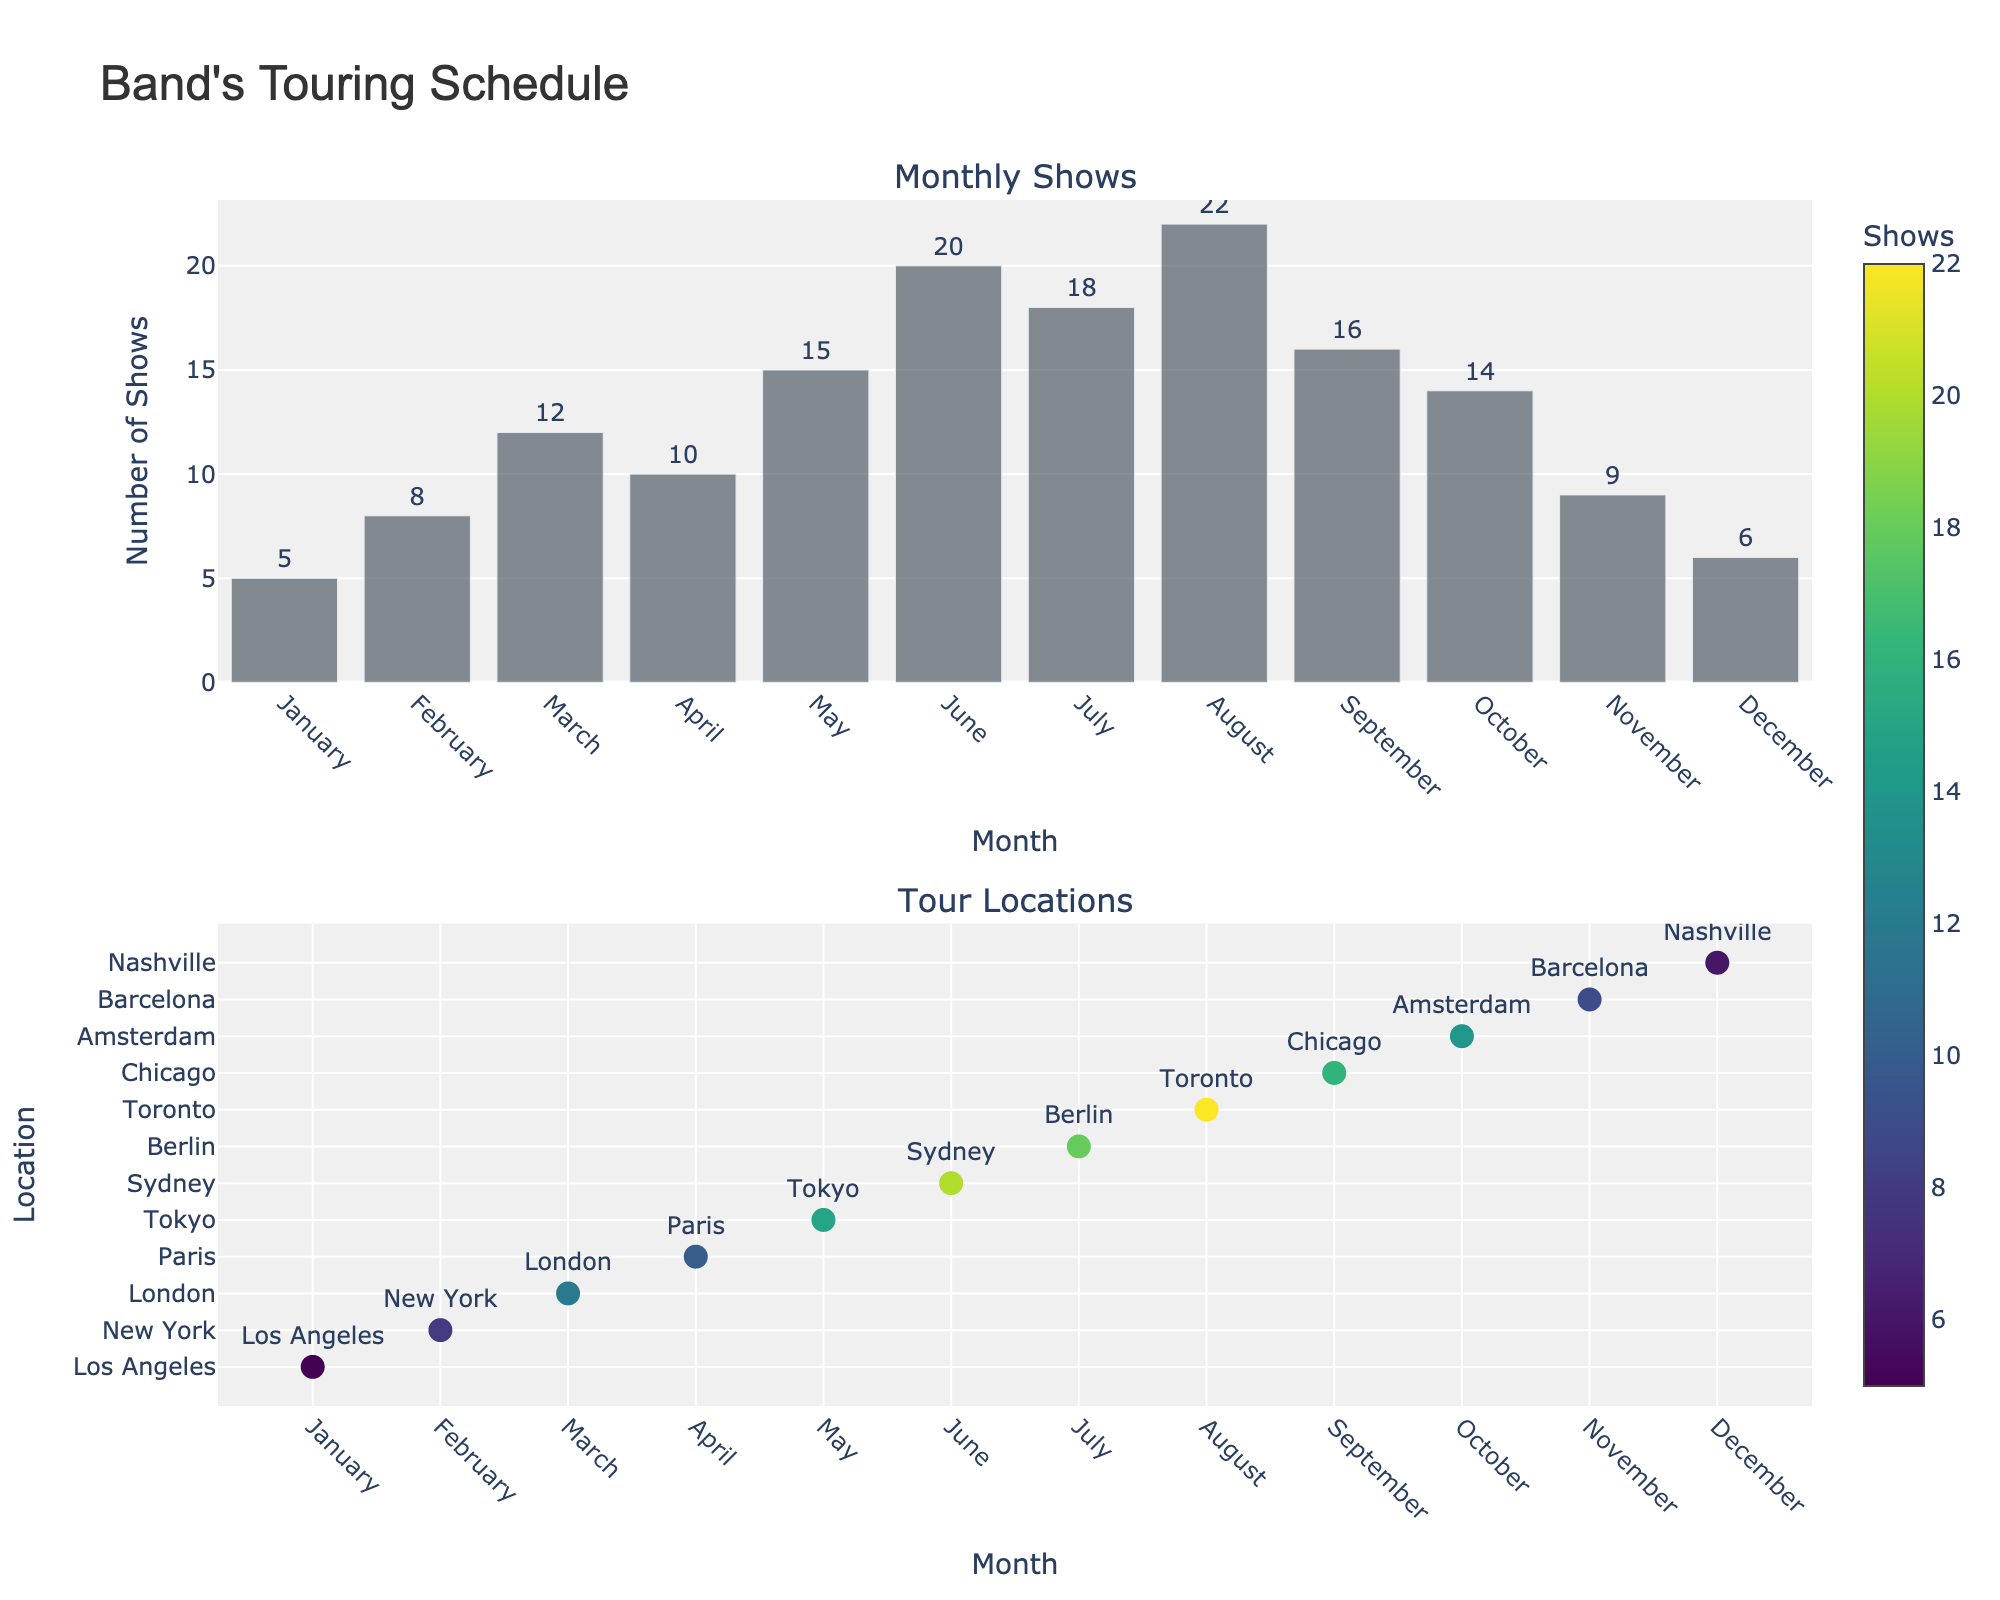What's the title of the figure? The title is usually displayed at the top of the figure. By looking at the figure, we can see that the title reads "Band's Touring Schedule."
Answer: Band's Touring Schedule How many shows did the band play in June? To find the number of shows played in June, look at the bar corresponding to June in the first subplot. The text label shows the number directly.
Answer: 20 Which month had the most shows? To determine the month with the most shows, look for the highest bar in the first subplot. The tallest bar is in August.
Answer: August What's the average number of shows per month? Calculate the average by summing the number of shows for each month and dividing by the number of months (12). (5+8+12+10+15+20+18+22+16+14+9+6)/12 = 13.25
Answer: 13.25 List all the locations where the band played shows in Europe. Look at the second subplot for locations and identify the ones in Europe. The European locations are London, Paris, Berlin, Amsterdam, and Barcelona.
Answer: London, Paris, Berlin, Amsterdam, Barcelona Which month had the lowest number of shows, and how many were there? Look for the shortest bar in the first subplot. The shortest bar is in January, showing 5 shows.
Answer: January, 5 Between July and August, which month had more shows, and how many more? Compare the bars for July and August in the first subplot. August (22) had more shows than July (18). The difference is 22 - 18 = 4.
Answer: August, 4 What is the total number of shows played by the band in the first quarter of the year? The first quarter includes January, February, and March. Add the number of shows in these months: 5 (Jan) + 8 (Feb) + 12 (Mar) = 25.
Answer: 25 Which two months had the closest number of shows, and what is the difference? By visually inspecting the bars in the first subplot, identify the closest ones. October (14) and November (9) show a difference of 1 show (although Berlin and Sydney might seem close but they are in different months).
Answer: October and November, 1 How many locations are displayed in the second subplot? Count the number of distinct markers in the second subplot. Each marker corresponds to a location, and there are 12 markers, one for each month.
Answer: 12 